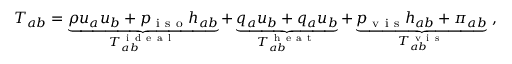Convert formula to latex. <formula><loc_0><loc_0><loc_500><loc_500>T _ { a b } = \underbrace { \rho u _ { a } u _ { b } + p _ { i s o } h _ { a b } } _ { T _ { a b } ^ { i d e a l } } + \underbrace { q _ { a } u _ { b } + q _ { a } u _ { b } } _ { T _ { a b } ^ { h e a t } } + \underbrace { p _ { v i s } h _ { a b } + \pi _ { a b } } _ { T _ { a b } ^ { v i s } } ,</formula> 